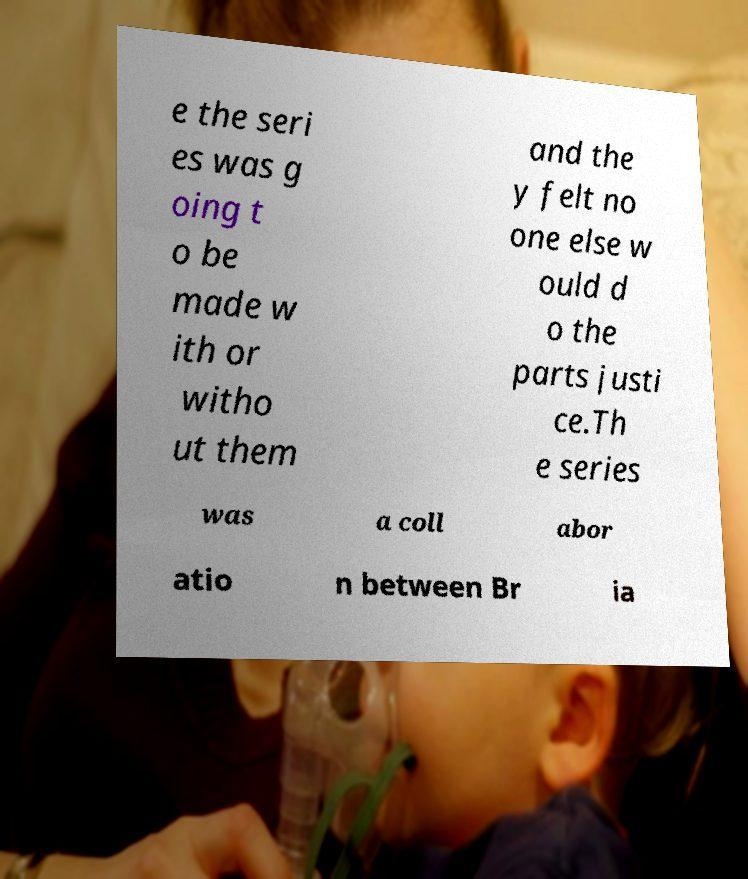There's text embedded in this image that I need extracted. Can you transcribe it verbatim? e the seri es was g oing t o be made w ith or witho ut them and the y felt no one else w ould d o the parts justi ce.Th e series was a coll abor atio n between Br ia 